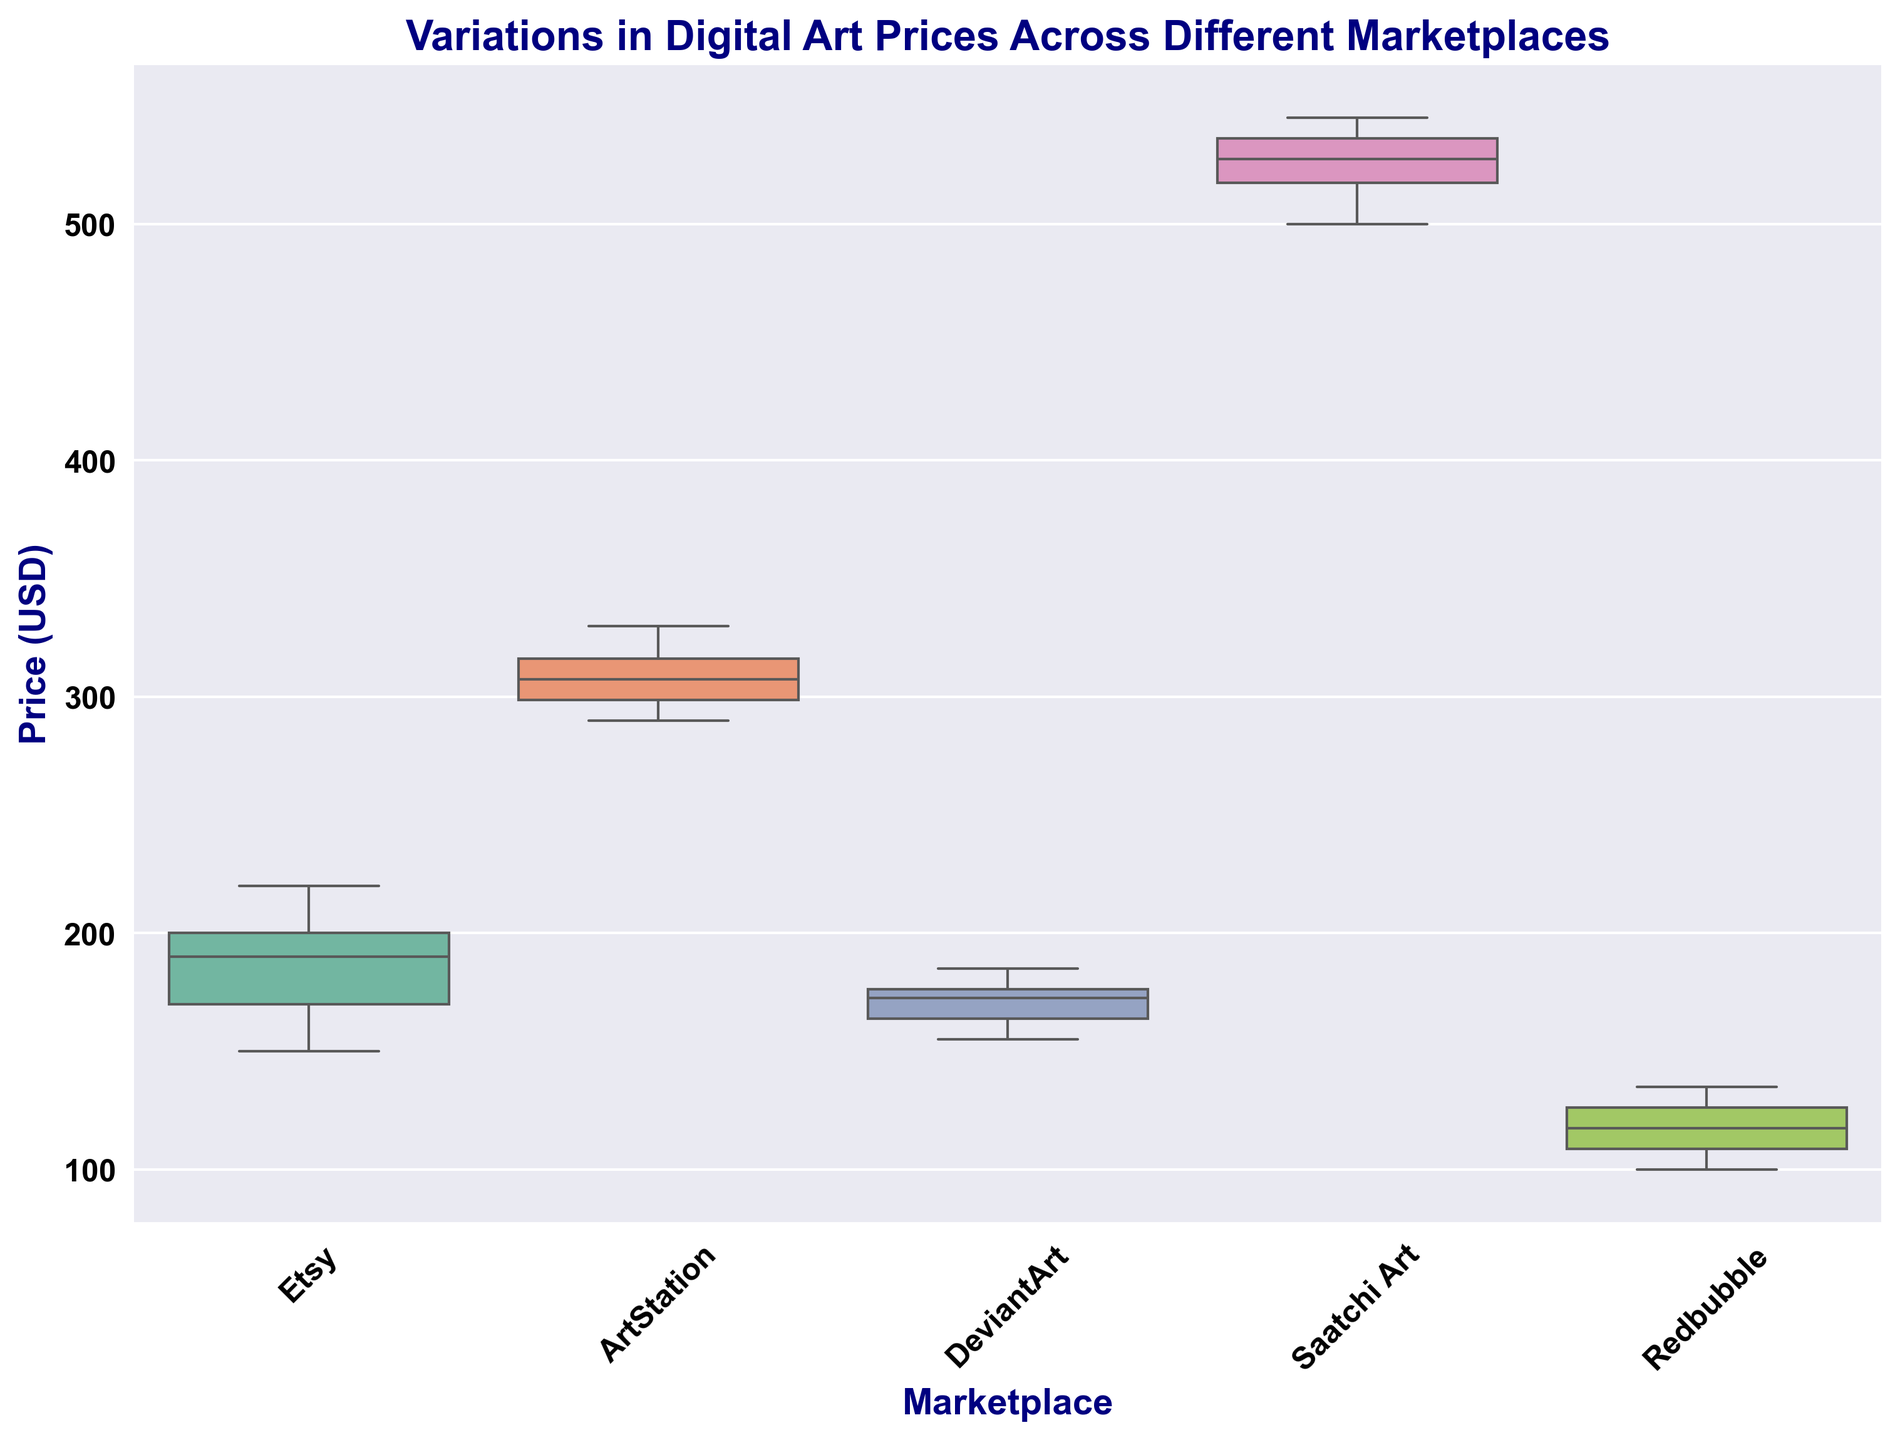What is the median price of digital art on ArtStation? The median is the middle value when the data points are ordered. For ArtStation: (290, 295, 300, 305, 310, 315, 320, 330). The middle values are 305 and 310. The median is (305 + 310) / 2 = 307.5
Answer: 307.5 Which marketplace has the highest median price? Identify the marketplace with the highest middle data point. Saatchi Art's median is higher compared to the others.
Answer: Saatchi Art How do the price ranges compare between DeviantArt and Redbubble? Compare the range (max-min) for each: DeviantArt (185-155=30), Redbubble (135-100=35). Redbubble has a wider range.
Answer: Redbubble Which marketplace has the lowest minimum price for digital art? Identify the lowest price point for each: Etsy (150), ArtStation (290), DeviantArt (155), Saatchi Art (500), Redbubble (100). Redbubble is the lowest.
Answer: Redbubble Is the interquartile range (IQR) of Saatchi Art greater than that of Etsy? Calculate IQR (Q3 - Q1): Saatchi Art Q3=535, Q1=510; IQR=535-510=25. Etsy Q3=210, Q1=170; IQR=210-170=40. Etsy's IQR is greater.
Answer: No What is the average price of digital art on DeviantArt? Sum and divide by count of prices: (155 + 160 + 165 + 170 + 175 + 175 + 180 + 185) / 8 = 171
Answer: 171 Which marketplace has the most consistent (least variable) prices? Compare the range of prices: Etsy (220-150), ArtStation (330-290), DeviantArt (185-155), Saatchi Art (545-500), Redbubble (135-100). DeviantArt has the smallest range.
Answer: DeviantArt What is the median price difference between Saatchi Art and Etsy? Saatchi Art median = 520, Etsy median = 195. Difference is 520 - 195 = 325
Answer: 325 Which two marketplaces have the closest median prices? Calculate the difference between medians: Differences (if not directly apparent, calculate) Redbubble (115) and DeviantArt (175), but addition et al have to be closest in comparison with medians of other marketplaces.
Answer: Etsy and DeviantArt What does the length of the box in the boxplot represent for each marketplace? The length of the box represents the interquartile range (IQR), which shows the spread of the middle 50% of the prices within each marketplace.
Answer: Interquartile range 